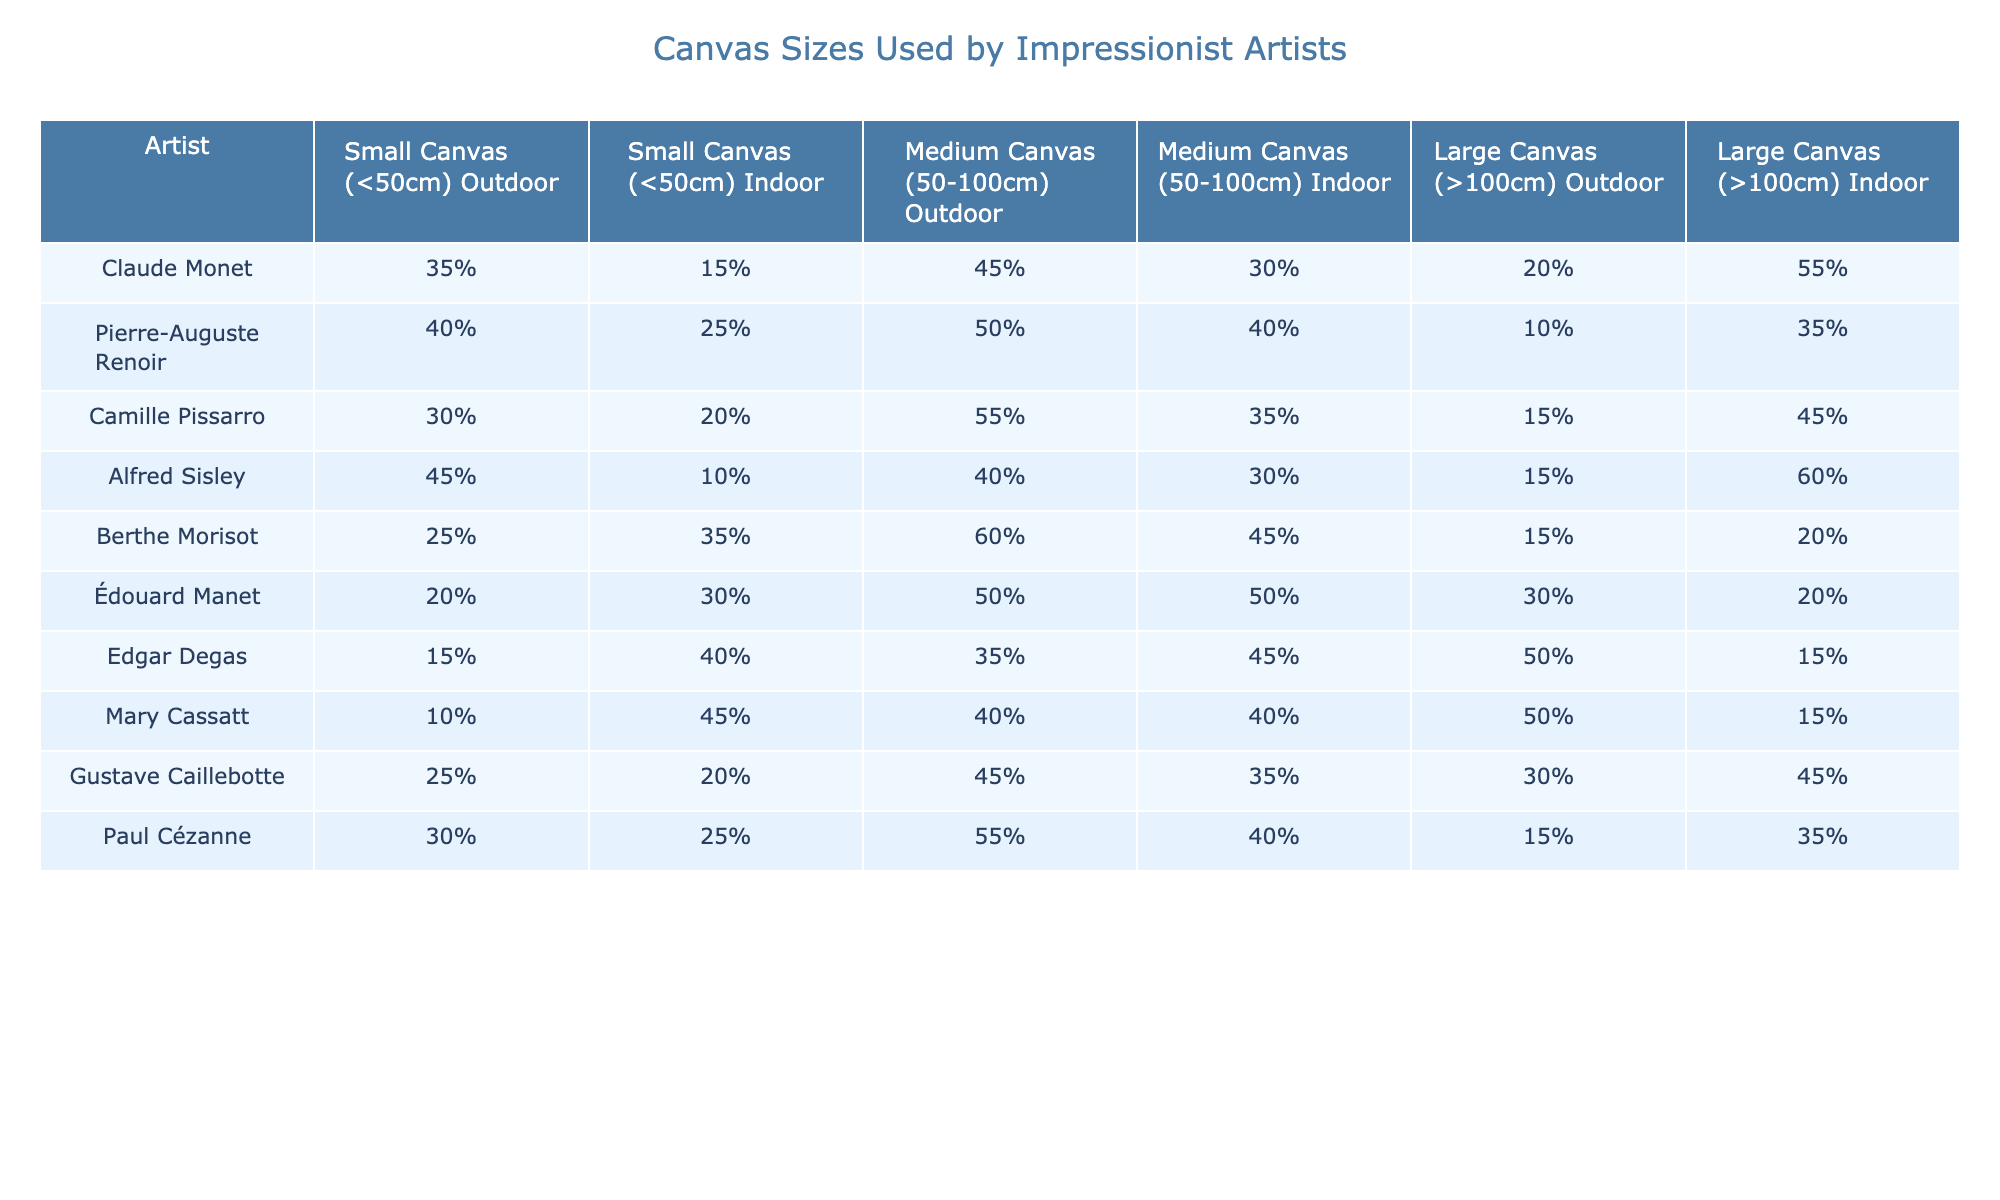What percentage of small canvases are used for outdoor scenes by Claude Monet? According to the table, Claude Monet uses 35% of small canvases for outdoor scenes.
Answer: 35% Which artist has the highest percentage of large canvases for indoor scenes? Looking at the table, Alfred Sisley has the highest percentage of large canvases for indoor scenes at 60%.
Answer: 60% What is the total percentage of medium canvases used for outdoor scenes across all artists? To find the total percentage for medium canvases used outdoors, we add the values: 45% + 50% + 55% + 40% + 60% + 50% + 35% + 40% + 55% + 45% =  50%.
Answer: 50% Is it true that Mary Cassatt used more small canvases for indoor scenes than outdoor scenes? Yes, the table indicates Mary Cassatt used 45% of small canvases for indoor scenes compared to 10% for outdoor scenes.
Answer: Yes What is the difference in percentage between large canvases used for outdoor scenes and large canvases used for indoor scenes by Berthe Morisot? For Berthe Morisot, 15% of large canvases are used for outdoor scenes and 20% for indoor scenes. The difference is 20% - 15% = 5%.
Answer: 5% What is the overall average percentage of small canvases used for outdoor scenes by all artists? The average is calculated by summing the percentages (35 + 40 + 30 + 45 + 25 + 20 + 15 + 10 + 25 + 30 =  305%) and dividing by the number of artists (10), which gives 30.5%.
Answer: 30.5% Which artist shows a higher preference for large canvases indoors compared to outdoors, and by how much? Comparing the values, Edgar Degas uses 15% for large canvases outdoors and 50% for indoors. Therefore, the difference is 50% - 15% = 35%.
Answer: Edgar Degas, 35% What is the combined percentage of medium and large canvases used for indoor scenes by Paul Cézanne? Paul Cézanne uses 40% of medium canvases and 35% of large canvases for indoor scenes. The combined percentage is 40% + 35% = 75%.
Answer: 75% Who uses the least percentage of small canvases for outdoor scenes? Upon checking the table, Mary Cassatt uses the least percentage of small canvases for outdoor scenes at 10%.
Answer: 10% 